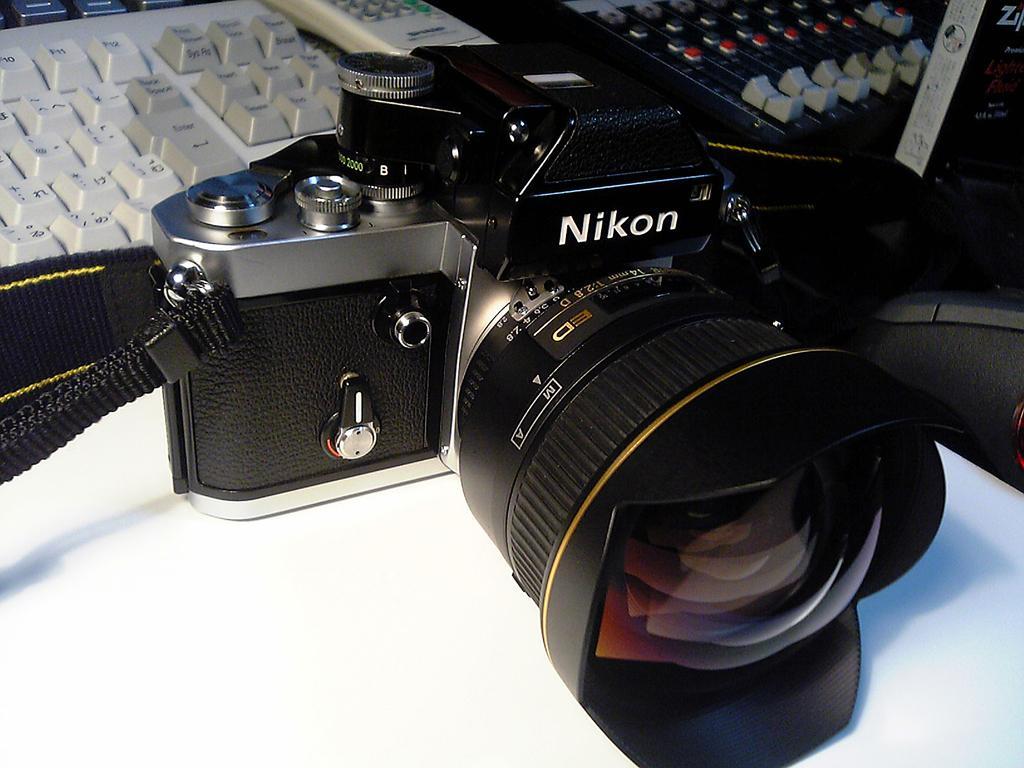Could you give a brief overview of what you see in this image? In this image we can see camera, keyboard, remote on the table. To the right side of the image there are other objects. 